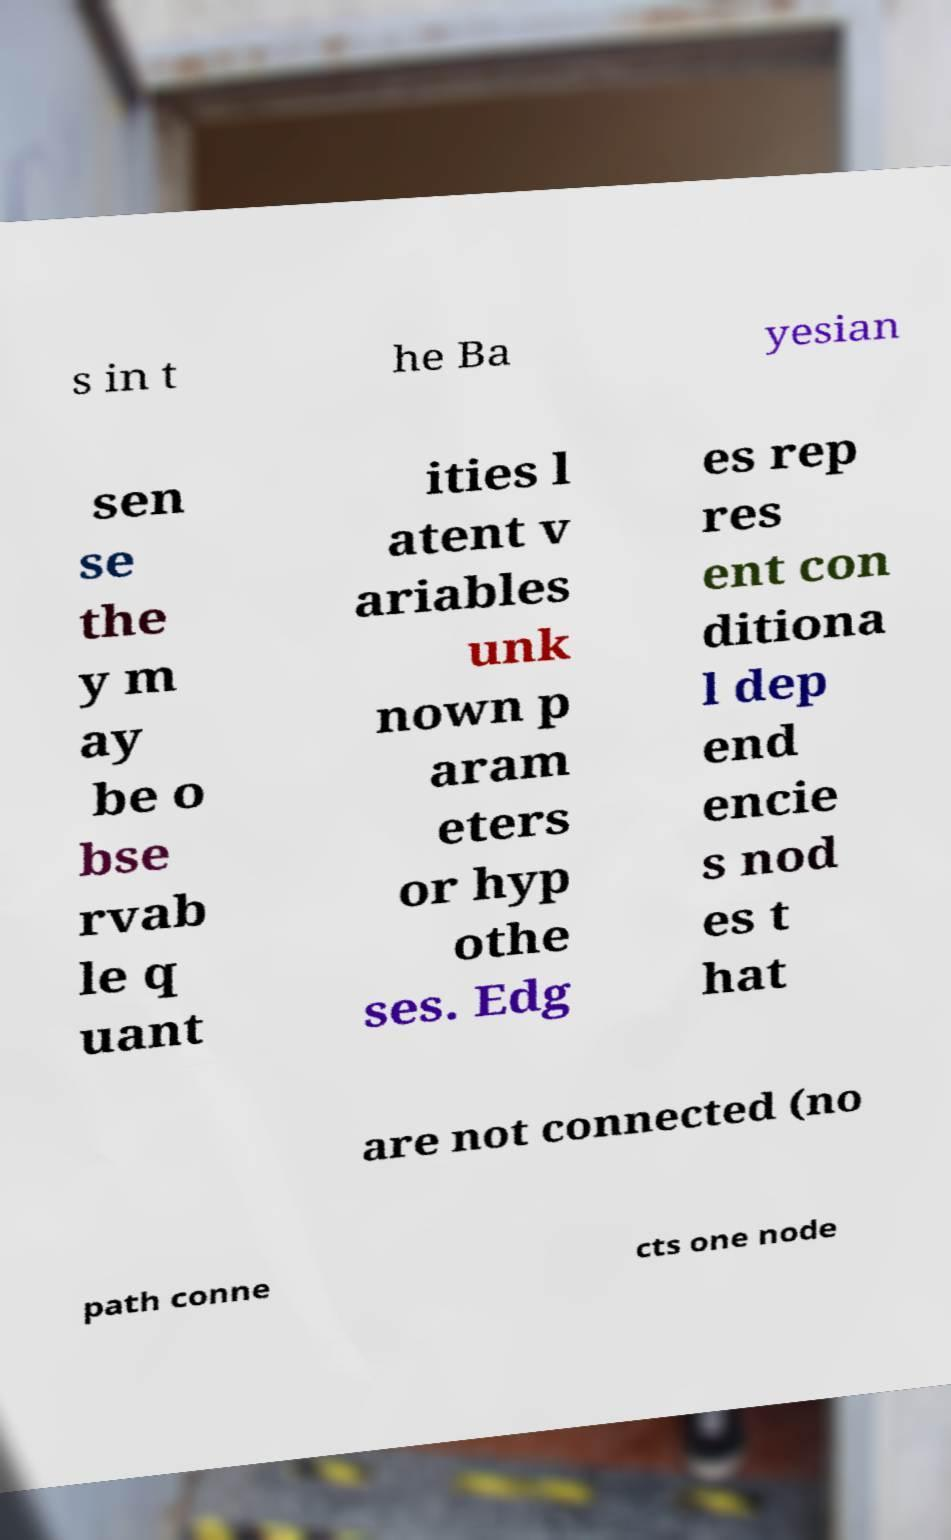Could you extract and type out the text from this image? s in t he Ba yesian sen se the y m ay be o bse rvab le q uant ities l atent v ariables unk nown p aram eters or hyp othe ses. Edg es rep res ent con ditiona l dep end encie s nod es t hat are not connected (no path conne cts one node 